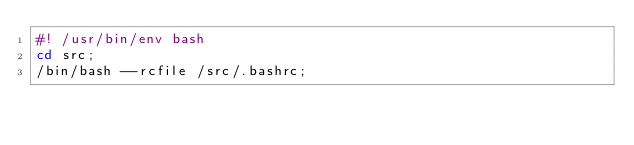Convert code to text. <code><loc_0><loc_0><loc_500><loc_500><_Bash_>#! /usr/bin/env bash
cd src;
/bin/bash --rcfile /src/.bashrc;

</code> 